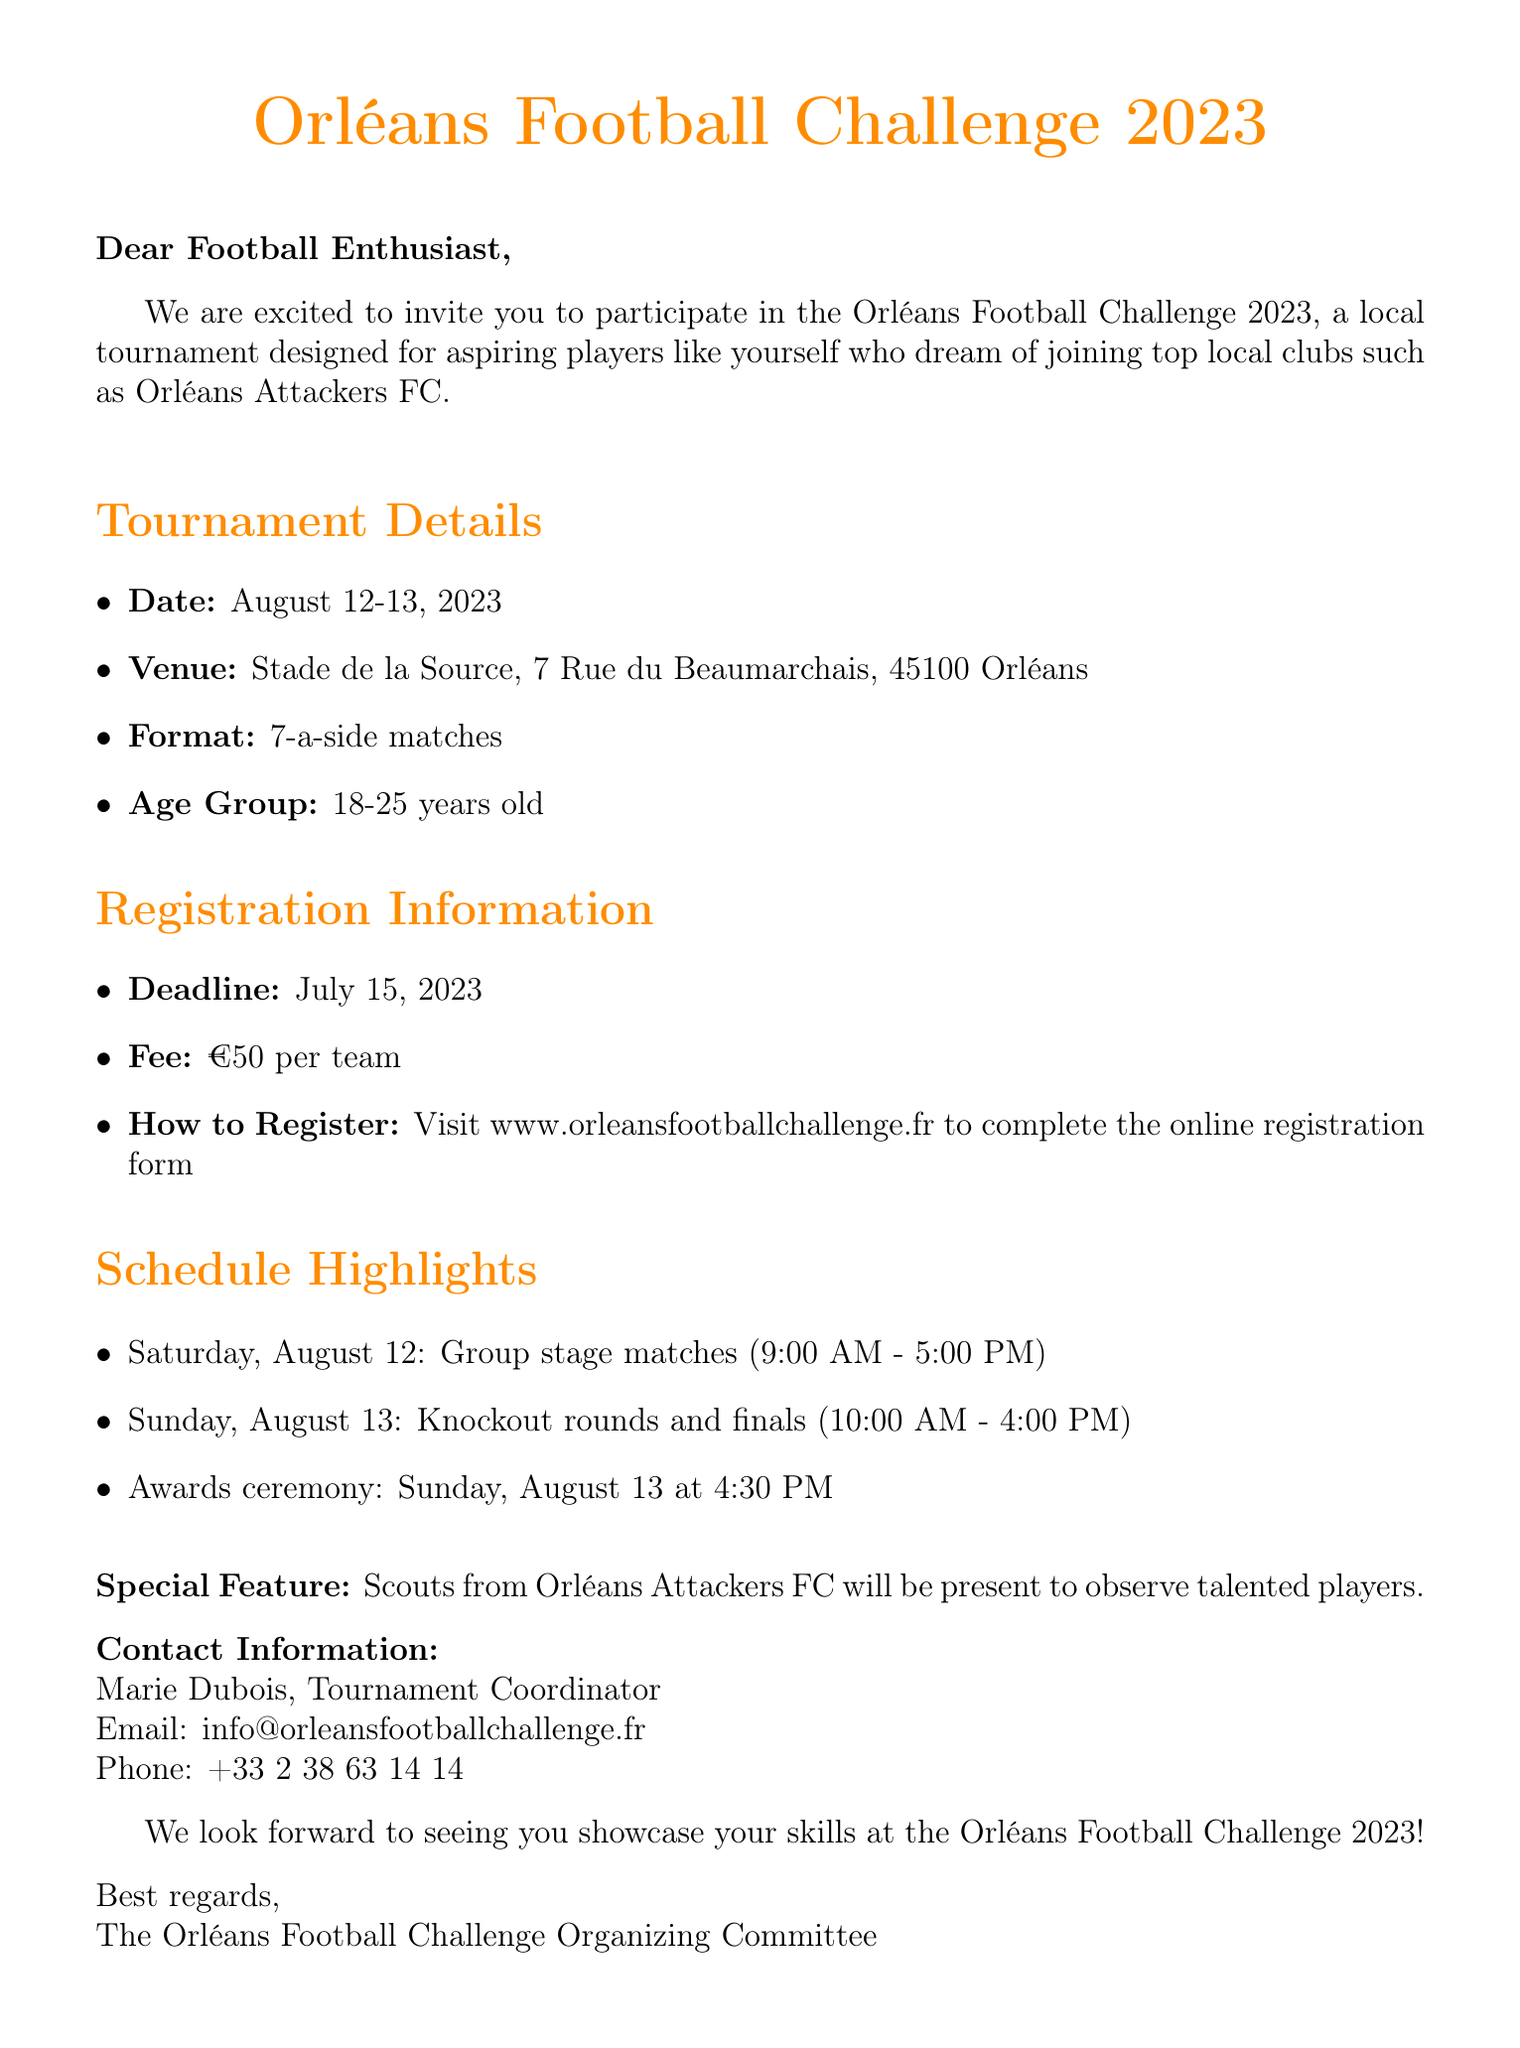What is the name of the tournament? The tournament is specifically named in the document.
Answer: Orléans Football Challenge 2023 What is the registration deadline? The deadline for registration is clearly stated in the document.
Answer: July 15, 2023 How much is the registration fee per team? The document specifies the registration fee amount.
Answer: €50 per team Where will the tournament take place? The venue for the tournament is provided in the document.
Answer: Stade de la Source, 7 Rue du Beaumarchais, 45100 Orléans What age group is eligible to participate? The document mentions the age range for participants.
Answer: 18-25 years old On which date will the awards ceremony occur? The document outlines the schedule, including the awards ceremony date.
Answer: August 13, 2023 What time do the knockout rounds start on Sunday? The document provides the schedule for the knockout rounds.
Answer: 10:00 AM Who should be contacted for more information? The document lists the contact person's name and title for inquiries.
Answer: Marie Dubois What special feature is mentioned regarding scouts? The document includes a note about scouts attending the tournament.
Answer: Scouts from Orléans Attackers FC will be present 